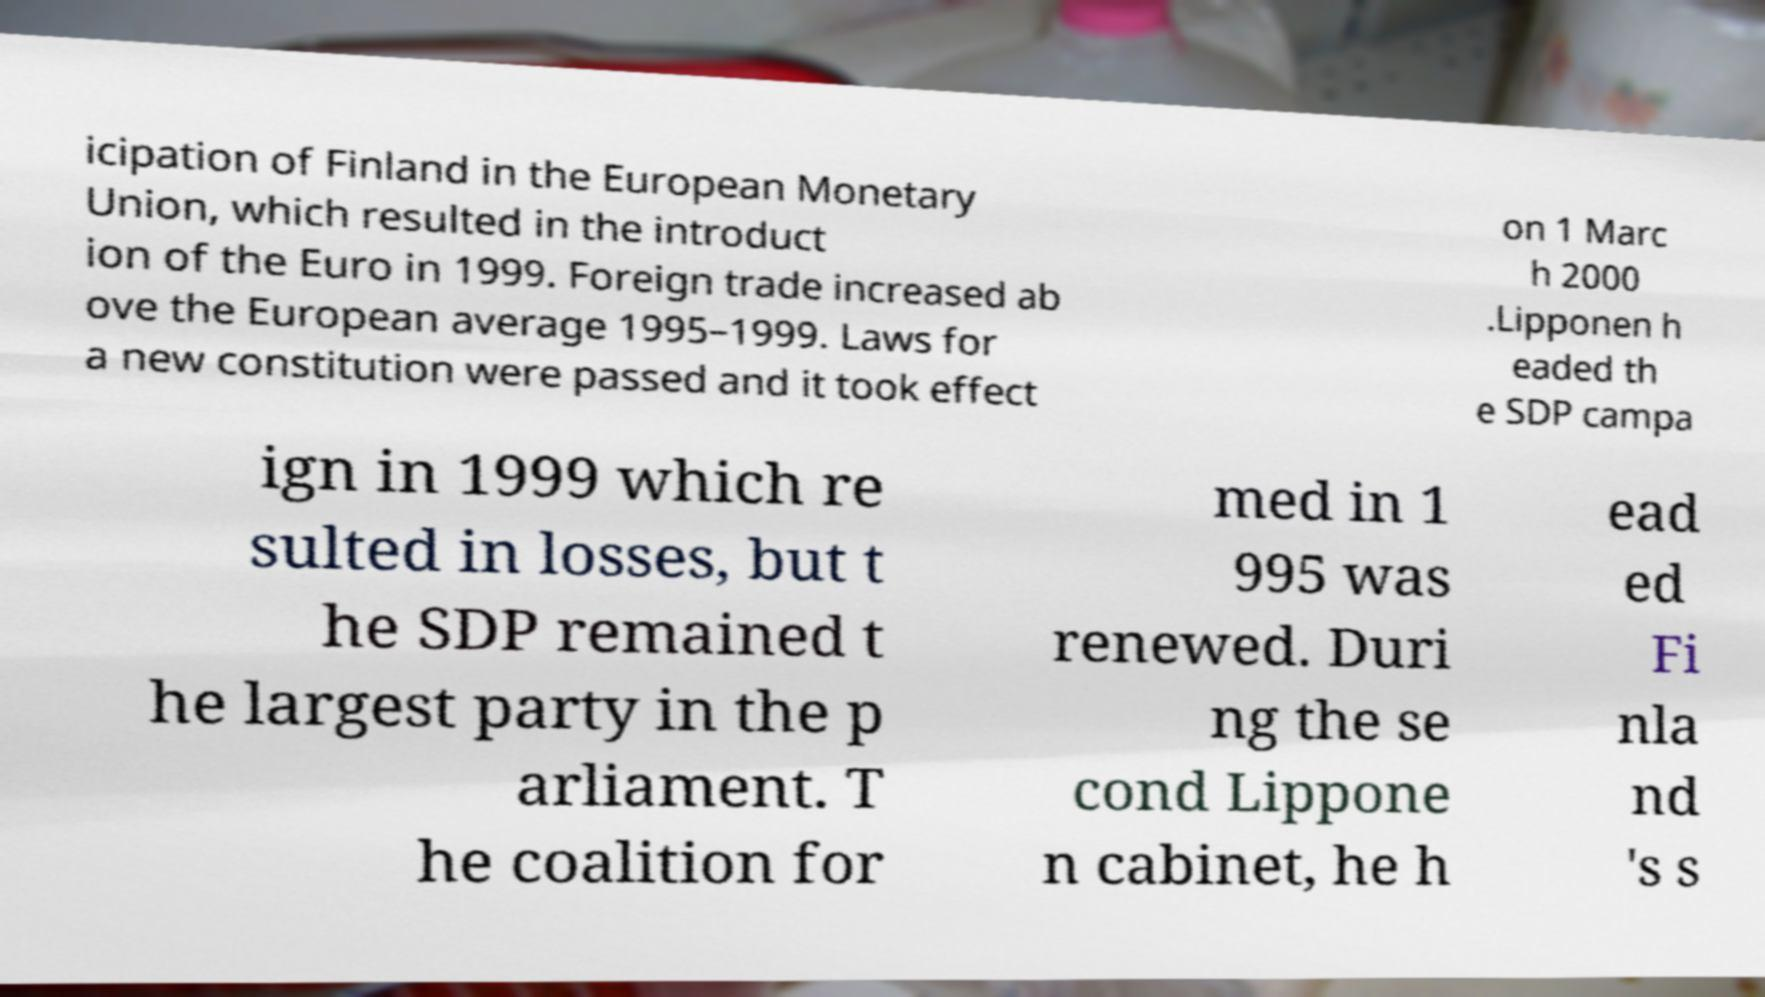Could you assist in decoding the text presented in this image and type it out clearly? icipation of Finland in the European Monetary Union, which resulted in the introduct ion of the Euro in 1999. Foreign trade increased ab ove the European average 1995–1999. Laws for a new constitution were passed and it took effect on 1 Marc h 2000 .Lipponen h eaded th e SDP campa ign in 1999 which re sulted in losses, but t he SDP remained t he largest party in the p arliament. T he coalition for med in 1 995 was renewed. Duri ng the se cond Lippone n cabinet, he h ead ed Fi nla nd 's s 